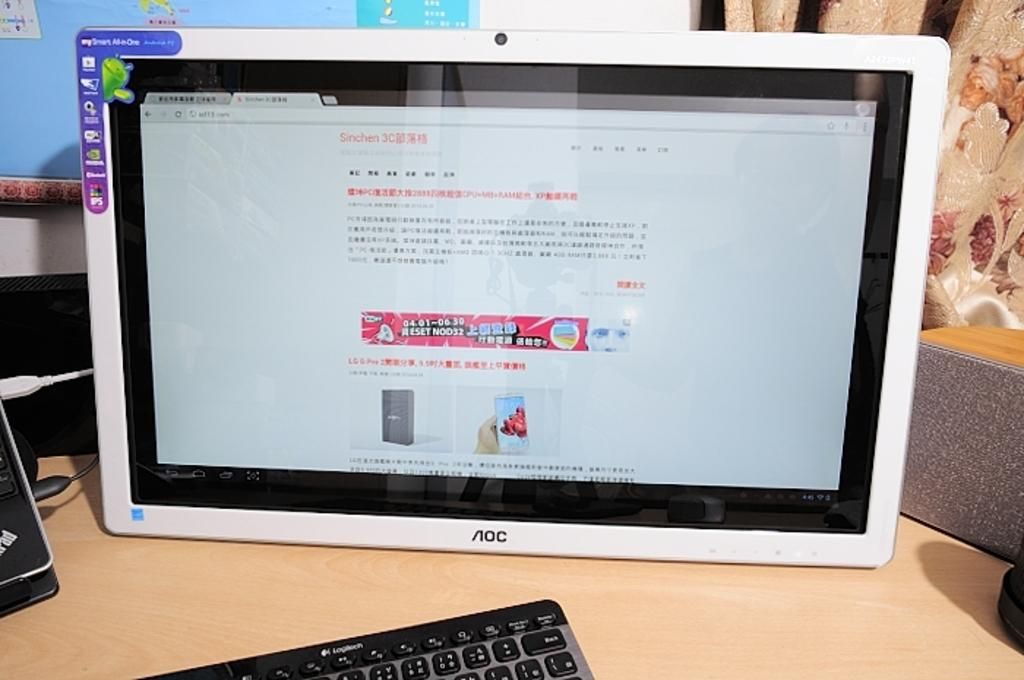What type of objects can be seen in the image? There are electronic gadgets in the image. What else is present in the image besides the electronic gadgets? Cables and a speaker are visible in the image. What is the surface on which the electronic gadgets and speaker are placed? There is a table in the image. Can you describe the right side of the image? Towards the right side of the image, there might be a curtain. What type of bird can be seen perched on the speaker in the image? There is no bird present in the image; it only features electronic gadgets, cables, a speaker, and a table. 